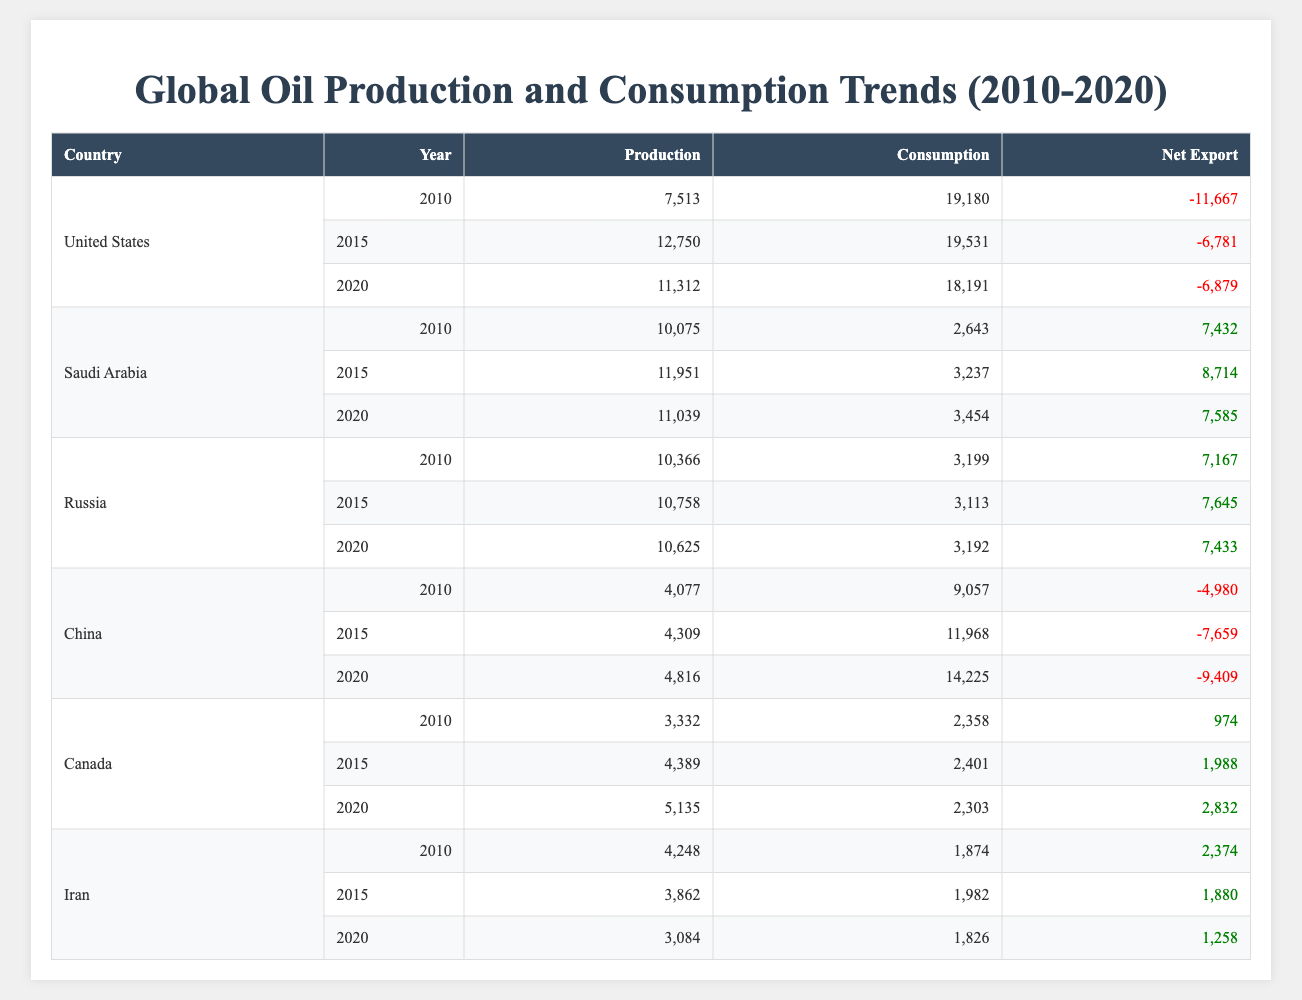What was the total oil production of Russia in 2015? In 2015, the oil production of Russia was 10,758 million barrels. This value can be directly retrieved from the table under the row corresponding to Russia for the year 2015.
Answer: 10,758 Which country had the highest net export in 2020? In 2020, Saudi Arabia had the highest net export of 7,585 million barrels. This can be found by comparing the net export values of all countries for the year 2020 in the table.
Answer: Saudi Arabia What is the difference in oil consumption for the United States between 2010 and 2020? The oil consumption for the United States in 2010 was 19,180 million barrels, and in 2020 it was 18,191 million barrels. The difference is calculated as 19,180 - 18,191 = 989 million barrels.
Answer: 989 Did Iran's oil production decrease from 2010 to 2020? Iran's oil production decreased from 4,248 million barrels in 2010 to 3,084 million barrels in 2020. Since 4,248 is greater than 3,084, this indicates a decrease in production.
Answer: Yes What was the average oil consumption for Canada from 2010 to 2020? The oil consumption values for Canada are 2,358 in 2010, 2,401 in 2015, and 2,303 in 2020. To calculate the average, sum these values: 2,358 + 2,401 + 2,303 = 7,062. Then divide by the number of years (3): 7,062 / 3 = 2,354.
Answer: 2,354 How much more oil did China consume in 2020 compared to 2015? The oil consumption for China in 2020 was 14,225 million barrels, and it was 11,968 million barrels in 2015. The difference is calculated as 14,225 - 11,968 = 2,257 million barrels, indicating an increase in consumption.
Answer: 2,257 What was the net export for Russia in 2015? The net export for Russia in 2015 was 7,645 million barrels. This data point can be directly retrieved from the relevant row and column in the table.
Answer: 7,645 Did any country have negative net export in 2015? Referring to the data for 2015, the United States shows a negative net export value of -6,781 million barrels, meaning it exported less oil than it consumed.
Answer: Yes What was the total oil production of the United States over the years 2010, 2015, and 2020? The production values for the United States in 2010, 2015, and 2020 are 7,513, 12,750, and 11,312 million barrels respectively. The total is calculated by summing these values: 7,513 + 12,750 + 11,312 = 31,575 million barrels.
Answer: 31,575 